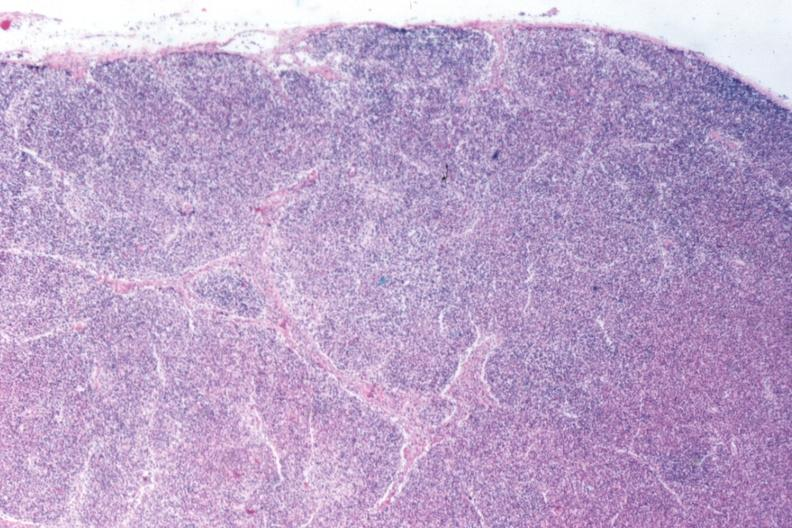s lymph node present?
Answer the question using a single word or phrase. Yes 